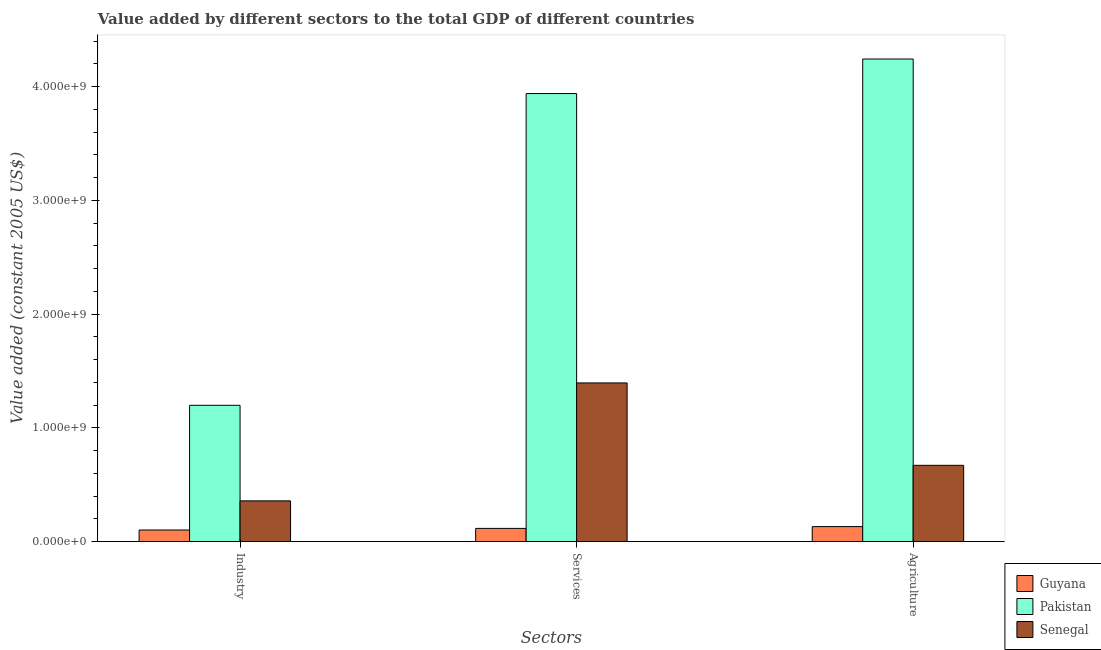Are the number of bars per tick equal to the number of legend labels?
Offer a terse response. Yes. How many bars are there on the 1st tick from the left?
Provide a succinct answer. 3. How many bars are there on the 2nd tick from the right?
Ensure brevity in your answer.  3. What is the label of the 1st group of bars from the left?
Ensure brevity in your answer.  Industry. What is the value added by services in Senegal?
Give a very brief answer. 1.39e+09. Across all countries, what is the maximum value added by agricultural sector?
Your answer should be compact. 4.24e+09. Across all countries, what is the minimum value added by services?
Provide a succinct answer. 1.16e+08. In which country was the value added by industrial sector maximum?
Keep it short and to the point. Pakistan. In which country was the value added by agricultural sector minimum?
Your answer should be very brief. Guyana. What is the total value added by agricultural sector in the graph?
Your response must be concise. 5.04e+09. What is the difference between the value added by agricultural sector in Pakistan and that in Senegal?
Provide a short and direct response. 3.57e+09. What is the difference between the value added by services in Senegal and the value added by industrial sector in Pakistan?
Provide a succinct answer. 1.97e+08. What is the average value added by agricultural sector per country?
Provide a succinct answer. 1.68e+09. What is the difference between the value added by industrial sector and value added by services in Guyana?
Give a very brief answer. -1.41e+07. What is the ratio of the value added by agricultural sector in Guyana to that in Senegal?
Give a very brief answer. 0.2. Is the value added by agricultural sector in Pakistan less than that in Senegal?
Provide a succinct answer. No. Is the difference between the value added by agricultural sector in Guyana and Senegal greater than the difference between the value added by services in Guyana and Senegal?
Offer a very short reply. Yes. What is the difference between the highest and the second highest value added by agricultural sector?
Provide a succinct answer. 3.57e+09. What is the difference between the highest and the lowest value added by industrial sector?
Offer a very short reply. 1.10e+09. In how many countries, is the value added by agricultural sector greater than the average value added by agricultural sector taken over all countries?
Keep it short and to the point. 1. Is the sum of the value added by industrial sector in Guyana and Pakistan greater than the maximum value added by agricultural sector across all countries?
Offer a terse response. No. What does the 3rd bar from the left in Agriculture represents?
Your answer should be very brief. Senegal. What does the 1st bar from the right in Agriculture represents?
Provide a short and direct response. Senegal. Is it the case that in every country, the sum of the value added by industrial sector and value added by services is greater than the value added by agricultural sector?
Ensure brevity in your answer.  Yes. How many bars are there?
Ensure brevity in your answer.  9. Are all the bars in the graph horizontal?
Give a very brief answer. No. How many countries are there in the graph?
Ensure brevity in your answer.  3. Does the graph contain any zero values?
Offer a very short reply. No. Does the graph contain grids?
Provide a short and direct response. No. What is the title of the graph?
Your response must be concise. Value added by different sectors to the total GDP of different countries. Does "Gambia, The" appear as one of the legend labels in the graph?
Ensure brevity in your answer.  No. What is the label or title of the X-axis?
Your response must be concise. Sectors. What is the label or title of the Y-axis?
Provide a succinct answer. Value added (constant 2005 US$). What is the Value added (constant 2005 US$) in Guyana in Industry?
Provide a short and direct response. 1.02e+08. What is the Value added (constant 2005 US$) in Pakistan in Industry?
Offer a terse response. 1.20e+09. What is the Value added (constant 2005 US$) of Senegal in Industry?
Offer a terse response. 3.58e+08. What is the Value added (constant 2005 US$) in Guyana in Services?
Make the answer very short. 1.16e+08. What is the Value added (constant 2005 US$) in Pakistan in Services?
Give a very brief answer. 3.94e+09. What is the Value added (constant 2005 US$) of Senegal in Services?
Make the answer very short. 1.39e+09. What is the Value added (constant 2005 US$) in Guyana in Agriculture?
Ensure brevity in your answer.  1.32e+08. What is the Value added (constant 2005 US$) of Pakistan in Agriculture?
Your answer should be very brief. 4.24e+09. What is the Value added (constant 2005 US$) of Senegal in Agriculture?
Your answer should be compact. 6.70e+08. Across all Sectors, what is the maximum Value added (constant 2005 US$) of Guyana?
Your answer should be compact. 1.32e+08. Across all Sectors, what is the maximum Value added (constant 2005 US$) in Pakistan?
Make the answer very short. 4.24e+09. Across all Sectors, what is the maximum Value added (constant 2005 US$) of Senegal?
Keep it short and to the point. 1.39e+09. Across all Sectors, what is the minimum Value added (constant 2005 US$) of Guyana?
Your answer should be very brief. 1.02e+08. Across all Sectors, what is the minimum Value added (constant 2005 US$) in Pakistan?
Give a very brief answer. 1.20e+09. Across all Sectors, what is the minimum Value added (constant 2005 US$) of Senegal?
Make the answer very short. 3.58e+08. What is the total Value added (constant 2005 US$) of Guyana in the graph?
Ensure brevity in your answer.  3.49e+08. What is the total Value added (constant 2005 US$) in Pakistan in the graph?
Keep it short and to the point. 9.38e+09. What is the total Value added (constant 2005 US$) of Senegal in the graph?
Keep it short and to the point. 2.42e+09. What is the difference between the Value added (constant 2005 US$) in Guyana in Industry and that in Services?
Your response must be concise. -1.41e+07. What is the difference between the Value added (constant 2005 US$) of Pakistan in Industry and that in Services?
Offer a terse response. -2.74e+09. What is the difference between the Value added (constant 2005 US$) of Senegal in Industry and that in Services?
Your answer should be compact. -1.04e+09. What is the difference between the Value added (constant 2005 US$) of Guyana in Industry and that in Agriculture?
Offer a terse response. -2.99e+07. What is the difference between the Value added (constant 2005 US$) in Pakistan in Industry and that in Agriculture?
Provide a short and direct response. -3.04e+09. What is the difference between the Value added (constant 2005 US$) of Senegal in Industry and that in Agriculture?
Offer a terse response. -3.13e+08. What is the difference between the Value added (constant 2005 US$) in Guyana in Services and that in Agriculture?
Offer a terse response. -1.58e+07. What is the difference between the Value added (constant 2005 US$) of Pakistan in Services and that in Agriculture?
Offer a very short reply. -3.04e+08. What is the difference between the Value added (constant 2005 US$) of Senegal in Services and that in Agriculture?
Offer a very short reply. 7.24e+08. What is the difference between the Value added (constant 2005 US$) in Guyana in Industry and the Value added (constant 2005 US$) in Pakistan in Services?
Provide a succinct answer. -3.84e+09. What is the difference between the Value added (constant 2005 US$) in Guyana in Industry and the Value added (constant 2005 US$) in Senegal in Services?
Offer a terse response. -1.29e+09. What is the difference between the Value added (constant 2005 US$) of Pakistan in Industry and the Value added (constant 2005 US$) of Senegal in Services?
Offer a terse response. -1.97e+08. What is the difference between the Value added (constant 2005 US$) in Guyana in Industry and the Value added (constant 2005 US$) in Pakistan in Agriculture?
Your response must be concise. -4.14e+09. What is the difference between the Value added (constant 2005 US$) in Guyana in Industry and the Value added (constant 2005 US$) in Senegal in Agriculture?
Your answer should be very brief. -5.69e+08. What is the difference between the Value added (constant 2005 US$) of Pakistan in Industry and the Value added (constant 2005 US$) of Senegal in Agriculture?
Your answer should be compact. 5.28e+08. What is the difference between the Value added (constant 2005 US$) of Guyana in Services and the Value added (constant 2005 US$) of Pakistan in Agriculture?
Your response must be concise. -4.13e+09. What is the difference between the Value added (constant 2005 US$) in Guyana in Services and the Value added (constant 2005 US$) in Senegal in Agriculture?
Your answer should be very brief. -5.55e+08. What is the difference between the Value added (constant 2005 US$) of Pakistan in Services and the Value added (constant 2005 US$) of Senegal in Agriculture?
Give a very brief answer. 3.27e+09. What is the average Value added (constant 2005 US$) in Guyana per Sectors?
Keep it short and to the point. 1.16e+08. What is the average Value added (constant 2005 US$) in Pakistan per Sectors?
Your answer should be very brief. 3.13e+09. What is the average Value added (constant 2005 US$) in Senegal per Sectors?
Make the answer very short. 8.08e+08. What is the difference between the Value added (constant 2005 US$) of Guyana and Value added (constant 2005 US$) of Pakistan in Industry?
Your response must be concise. -1.10e+09. What is the difference between the Value added (constant 2005 US$) in Guyana and Value added (constant 2005 US$) in Senegal in Industry?
Your answer should be very brief. -2.56e+08. What is the difference between the Value added (constant 2005 US$) of Pakistan and Value added (constant 2005 US$) of Senegal in Industry?
Provide a short and direct response. 8.40e+08. What is the difference between the Value added (constant 2005 US$) in Guyana and Value added (constant 2005 US$) in Pakistan in Services?
Ensure brevity in your answer.  -3.82e+09. What is the difference between the Value added (constant 2005 US$) of Guyana and Value added (constant 2005 US$) of Senegal in Services?
Your answer should be very brief. -1.28e+09. What is the difference between the Value added (constant 2005 US$) of Pakistan and Value added (constant 2005 US$) of Senegal in Services?
Offer a terse response. 2.54e+09. What is the difference between the Value added (constant 2005 US$) of Guyana and Value added (constant 2005 US$) of Pakistan in Agriculture?
Keep it short and to the point. -4.11e+09. What is the difference between the Value added (constant 2005 US$) of Guyana and Value added (constant 2005 US$) of Senegal in Agriculture?
Provide a short and direct response. -5.39e+08. What is the difference between the Value added (constant 2005 US$) of Pakistan and Value added (constant 2005 US$) of Senegal in Agriculture?
Provide a short and direct response. 3.57e+09. What is the ratio of the Value added (constant 2005 US$) of Guyana in Industry to that in Services?
Provide a succinct answer. 0.88. What is the ratio of the Value added (constant 2005 US$) of Pakistan in Industry to that in Services?
Offer a very short reply. 0.3. What is the ratio of the Value added (constant 2005 US$) in Senegal in Industry to that in Services?
Provide a short and direct response. 0.26. What is the ratio of the Value added (constant 2005 US$) in Guyana in Industry to that in Agriculture?
Make the answer very short. 0.77. What is the ratio of the Value added (constant 2005 US$) in Pakistan in Industry to that in Agriculture?
Keep it short and to the point. 0.28. What is the ratio of the Value added (constant 2005 US$) of Senegal in Industry to that in Agriculture?
Your response must be concise. 0.53. What is the ratio of the Value added (constant 2005 US$) of Guyana in Services to that in Agriculture?
Give a very brief answer. 0.88. What is the ratio of the Value added (constant 2005 US$) of Pakistan in Services to that in Agriculture?
Ensure brevity in your answer.  0.93. What is the ratio of the Value added (constant 2005 US$) in Senegal in Services to that in Agriculture?
Keep it short and to the point. 2.08. What is the difference between the highest and the second highest Value added (constant 2005 US$) of Guyana?
Make the answer very short. 1.58e+07. What is the difference between the highest and the second highest Value added (constant 2005 US$) of Pakistan?
Keep it short and to the point. 3.04e+08. What is the difference between the highest and the second highest Value added (constant 2005 US$) in Senegal?
Offer a very short reply. 7.24e+08. What is the difference between the highest and the lowest Value added (constant 2005 US$) in Guyana?
Offer a very short reply. 2.99e+07. What is the difference between the highest and the lowest Value added (constant 2005 US$) of Pakistan?
Keep it short and to the point. 3.04e+09. What is the difference between the highest and the lowest Value added (constant 2005 US$) of Senegal?
Your answer should be compact. 1.04e+09. 